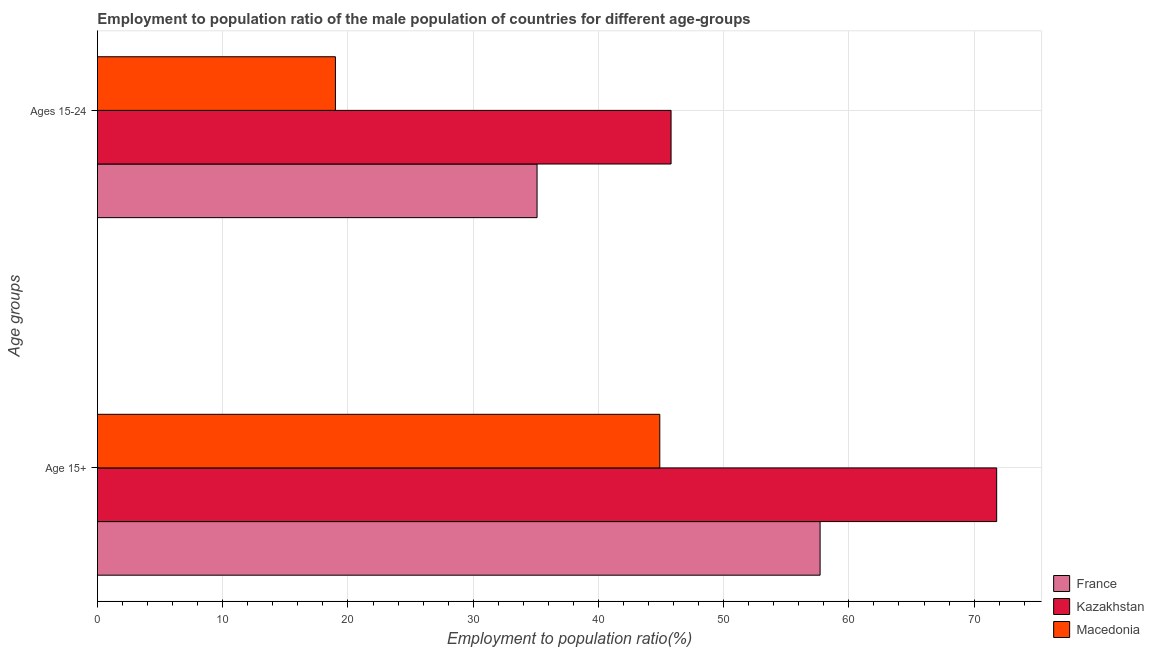Are the number of bars per tick equal to the number of legend labels?
Keep it short and to the point. Yes. Are the number of bars on each tick of the Y-axis equal?
Offer a very short reply. Yes. How many bars are there on the 2nd tick from the bottom?
Provide a succinct answer. 3. What is the label of the 2nd group of bars from the top?
Your answer should be compact. Age 15+. What is the employment to population ratio(age 15-24) in France?
Your answer should be very brief. 35.1. Across all countries, what is the maximum employment to population ratio(age 15+)?
Ensure brevity in your answer.  71.8. Across all countries, what is the minimum employment to population ratio(age 15-24)?
Your answer should be very brief. 19. In which country was the employment to population ratio(age 15-24) maximum?
Give a very brief answer. Kazakhstan. In which country was the employment to population ratio(age 15-24) minimum?
Provide a short and direct response. Macedonia. What is the total employment to population ratio(age 15+) in the graph?
Offer a terse response. 174.4. What is the difference between the employment to population ratio(age 15-24) in Kazakhstan and that in Macedonia?
Make the answer very short. 26.8. What is the difference between the employment to population ratio(age 15-24) in Macedonia and the employment to population ratio(age 15+) in Kazakhstan?
Your answer should be compact. -52.8. What is the average employment to population ratio(age 15+) per country?
Make the answer very short. 58.13. What is the difference between the employment to population ratio(age 15+) and employment to population ratio(age 15-24) in France?
Ensure brevity in your answer.  22.6. What is the ratio of the employment to population ratio(age 15+) in Macedonia to that in France?
Ensure brevity in your answer.  0.78. Is the employment to population ratio(age 15-24) in France less than that in Macedonia?
Your answer should be compact. No. In how many countries, is the employment to population ratio(age 15-24) greater than the average employment to population ratio(age 15-24) taken over all countries?
Keep it short and to the point. 2. What does the 2nd bar from the top in Age 15+ represents?
Offer a terse response. Kazakhstan. What does the 1st bar from the bottom in Ages 15-24 represents?
Keep it short and to the point. France. How many bars are there?
Offer a terse response. 6. Are all the bars in the graph horizontal?
Your response must be concise. Yes. What is the difference between two consecutive major ticks on the X-axis?
Your answer should be very brief. 10. Are the values on the major ticks of X-axis written in scientific E-notation?
Offer a very short reply. No. What is the title of the graph?
Provide a short and direct response. Employment to population ratio of the male population of countries for different age-groups. What is the label or title of the Y-axis?
Your answer should be very brief. Age groups. What is the Employment to population ratio(%) in France in Age 15+?
Give a very brief answer. 57.7. What is the Employment to population ratio(%) of Kazakhstan in Age 15+?
Keep it short and to the point. 71.8. What is the Employment to population ratio(%) of Macedonia in Age 15+?
Your response must be concise. 44.9. What is the Employment to population ratio(%) of France in Ages 15-24?
Keep it short and to the point. 35.1. What is the Employment to population ratio(%) of Kazakhstan in Ages 15-24?
Make the answer very short. 45.8. Across all Age groups, what is the maximum Employment to population ratio(%) of France?
Ensure brevity in your answer.  57.7. Across all Age groups, what is the maximum Employment to population ratio(%) of Kazakhstan?
Give a very brief answer. 71.8. Across all Age groups, what is the maximum Employment to population ratio(%) of Macedonia?
Provide a succinct answer. 44.9. Across all Age groups, what is the minimum Employment to population ratio(%) in France?
Your answer should be very brief. 35.1. Across all Age groups, what is the minimum Employment to population ratio(%) in Kazakhstan?
Your response must be concise. 45.8. Across all Age groups, what is the minimum Employment to population ratio(%) in Macedonia?
Keep it short and to the point. 19. What is the total Employment to population ratio(%) in France in the graph?
Provide a short and direct response. 92.8. What is the total Employment to population ratio(%) in Kazakhstan in the graph?
Your response must be concise. 117.6. What is the total Employment to population ratio(%) in Macedonia in the graph?
Your response must be concise. 63.9. What is the difference between the Employment to population ratio(%) in France in Age 15+ and that in Ages 15-24?
Make the answer very short. 22.6. What is the difference between the Employment to population ratio(%) in Kazakhstan in Age 15+ and that in Ages 15-24?
Your answer should be compact. 26. What is the difference between the Employment to population ratio(%) in Macedonia in Age 15+ and that in Ages 15-24?
Ensure brevity in your answer.  25.9. What is the difference between the Employment to population ratio(%) of France in Age 15+ and the Employment to population ratio(%) of Kazakhstan in Ages 15-24?
Give a very brief answer. 11.9. What is the difference between the Employment to population ratio(%) in France in Age 15+ and the Employment to population ratio(%) in Macedonia in Ages 15-24?
Keep it short and to the point. 38.7. What is the difference between the Employment to population ratio(%) of Kazakhstan in Age 15+ and the Employment to population ratio(%) of Macedonia in Ages 15-24?
Keep it short and to the point. 52.8. What is the average Employment to population ratio(%) of France per Age groups?
Keep it short and to the point. 46.4. What is the average Employment to population ratio(%) of Kazakhstan per Age groups?
Provide a short and direct response. 58.8. What is the average Employment to population ratio(%) of Macedonia per Age groups?
Make the answer very short. 31.95. What is the difference between the Employment to population ratio(%) of France and Employment to population ratio(%) of Kazakhstan in Age 15+?
Your response must be concise. -14.1. What is the difference between the Employment to population ratio(%) of Kazakhstan and Employment to population ratio(%) of Macedonia in Age 15+?
Offer a very short reply. 26.9. What is the difference between the Employment to population ratio(%) in France and Employment to population ratio(%) in Kazakhstan in Ages 15-24?
Keep it short and to the point. -10.7. What is the difference between the Employment to population ratio(%) in Kazakhstan and Employment to population ratio(%) in Macedonia in Ages 15-24?
Provide a succinct answer. 26.8. What is the ratio of the Employment to population ratio(%) in France in Age 15+ to that in Ages 15-24?
Offer a very short reply. 1.64. What is the ratio of the Employment to population ratio(%) in Kazakhstan in Age 15+ to that in Ages 15-24?
Your response must be concise. 1.57. What is the ratio of the Employment to population ratio(%) in Macedonia in Age 15+ to that in Ages 15-24?
Your response must be concise. 2.36. What is the difference between the highest and the second highest Employment to population ratio(%) in France?
Offer a very short reply. 22.6. What is the difference between the highest and the second highest Employment to population ratio(%) in Macedonia?
Ensure brevity in your answer.  25.9. What is the difference between the highest and the lowest Employment to population ratio(%) in France?
Offer a terse response. 22.6. What is the difference between the highest and the lowest Employment to population ratio(%) of Macedonia?
Your answer should be very brief. 25.9. 